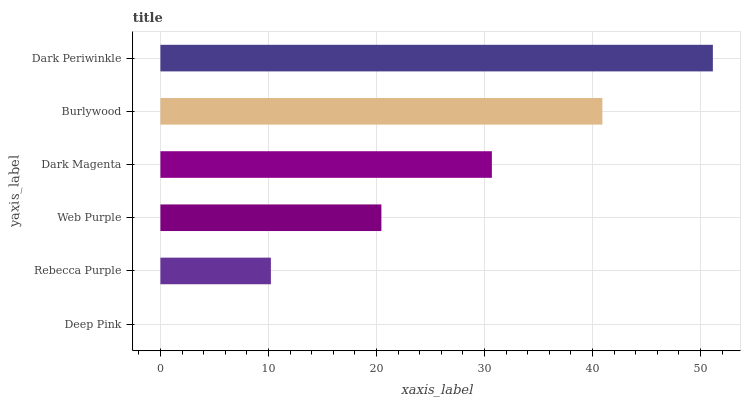Is Deep Pink the minimum?
Answer yes or no. Yes. Is Dark Periwinkle the maximum?
Answer yes or no. Yes. Is Rebecca Purple the minimum?
Answer yes or no. No. Is Rebecca Purple the maximum?
Answer yes or no. No. Is Rebecca Purple greater than Deep Pink?
Answer yes or no. Yes. Is Deep Pink less than Rebecca Purple?
Answer yes or no. Yes. Is Deep Pink greater than Rebecca Purple?
Answer yes or no. No. Is Rebecca Purple less than Deep Pink?
Answer yes or no. No. Is Dark Magenta the high median?
Answer yes or no. Yes. Is Web Purple the low median?
Answer yes or no. Yes. Is Rebecca Purple the high median?
Answer yes or no. No. Is Rebecca Purple the low median?
Answer yes or no. No. 